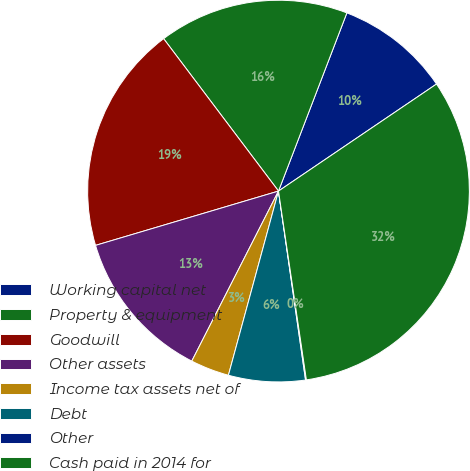Convert chart to OTSL. <chart><loc_0><loc_0><loc_500><loc_500><pie_chart><fcel>Working capital net<fcel>Property & equipment<fcel>Goodwill<fcel>Other assets<fcel>Income tax assets net of<fcel>Debt<fcel>Other<fcel>Cash paid in 2014 for<nl><fcel>9.69%<fcel>16.11%<fcel>19.31%<fcel>12.9%<fcel>3.28%<fcel>6.49%<fcel>0.07%<fcel>32.14%<nl></chart> 